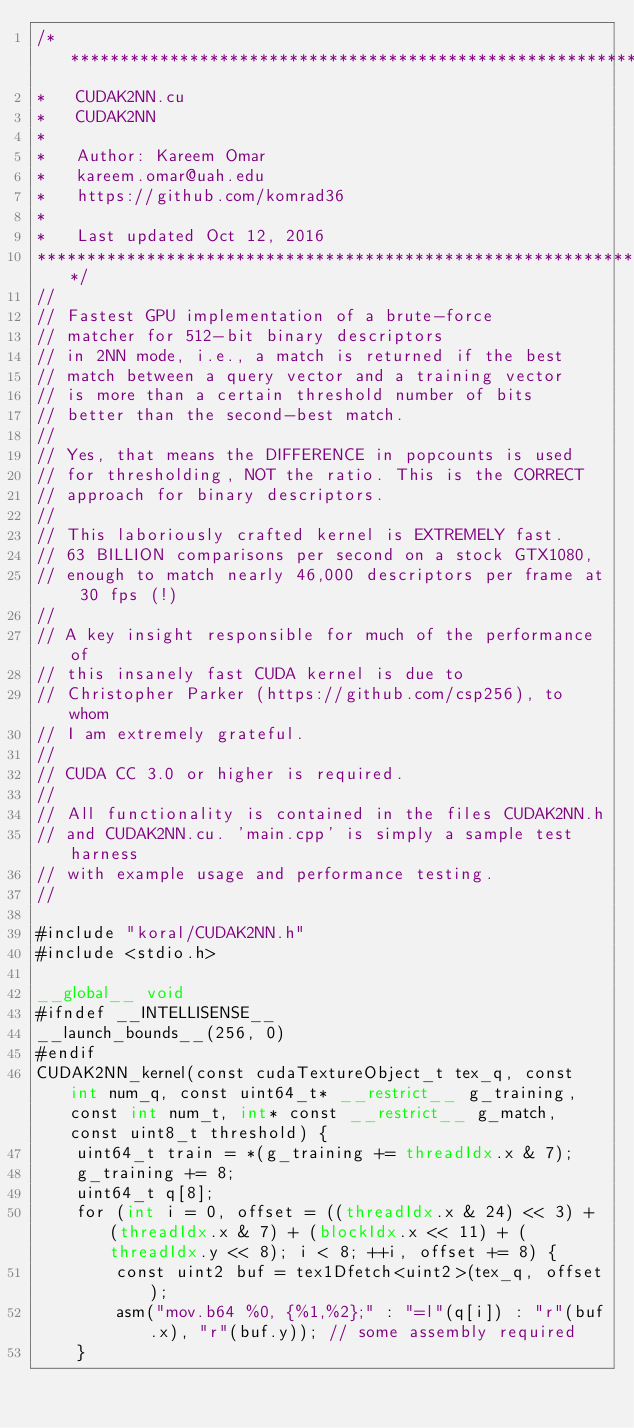Convert code to text. <code><loc_0><loc_0><loc_500><loc_500><_Cuda_>/*******************************************************************
*   CUDAK2NN.cu
*   CUDAK2NN
*
*	Author: Kareem Omar
*	kareem.omar@uah.edu
*	https://github.com/komrad36
*
*	Last updated Oct 12, 2016
*******************************************************************/
//
// Fastest GPU implementation of a brute-force
// matcher for 512-bit binary descriptors
// in 2NN mode, i.e., a match is returned if the best
// match between a query vector and a training vector
// is more than a certain threshold number of bits
// better than the second-best match.
//
// Yes, that means the DIFFERENCE in popcounts is used
// for thresholding, NOT the ratio. This is the CORRECT
// approach for binary descriptors.
//
// This laboriously crafted kernel is EXTREMELY fast.
// 63 BILLION comparisons per second on a stock GTX1080,
// enough to match nearly 46,000 descriptors per frame at 30 fps (!)
//
// A key insight responsible for much of the performance of
// this insanely fast CUDA kernel is due to
// Christopher Parker (https://github.com/csp256), to whom
// I am extremely grateful.
//
// CUDA CC 3.0 or higher is required.
//
// All functionality is contained in the files CUDAK2NN.h
// and CUDAK2NN.cu. 'main.cpp' is simply a sample test harness
// with example usage and performance testing.
//

#include "koral/CUDAK2NN.h"
#include <stdio.h>

__global__ void
#ifndef __INTELLISENSE__
__launch_bounds__(256, 0)
#endif
CUDAK2NN_kernel(const cudaTextureObject_t tex_q, const int num_q, const uint64_t* __restrict__ g_training, const int num_t, int* const __restrict__ g_match, const uint8_t threshold) {
	uint64_t train = *(g_training += threadIdx.x & 7);
	g_training += 8;
	uint64_t q[8];
	for (int i = 0, offset = ((threadIdx.x & 24) << 3) + (threadIdx.x & 7) + (blockIdx.x << 11) + (threadIdx.y << 8); i < 8; ++i, offset += 8) {
		const uint2 buf = tex1Dfetch<uint2>(tex_q, offset);
		asm("mov.b64 %0, {%1,%2};" : "=l"(q[i]) : "r"(buf.x), "r"(buf.y)); // some assembly required
	}	</code> 